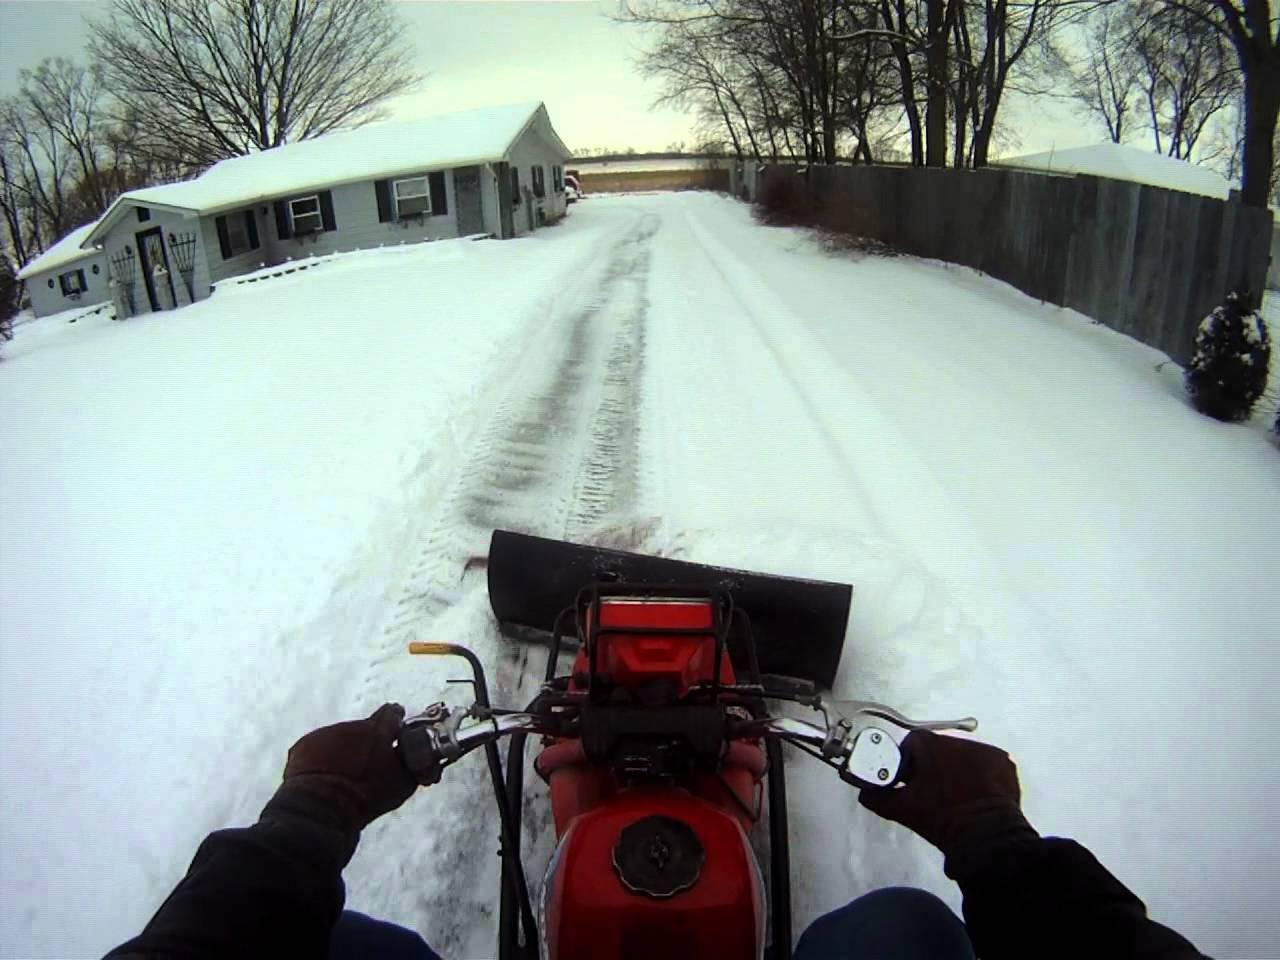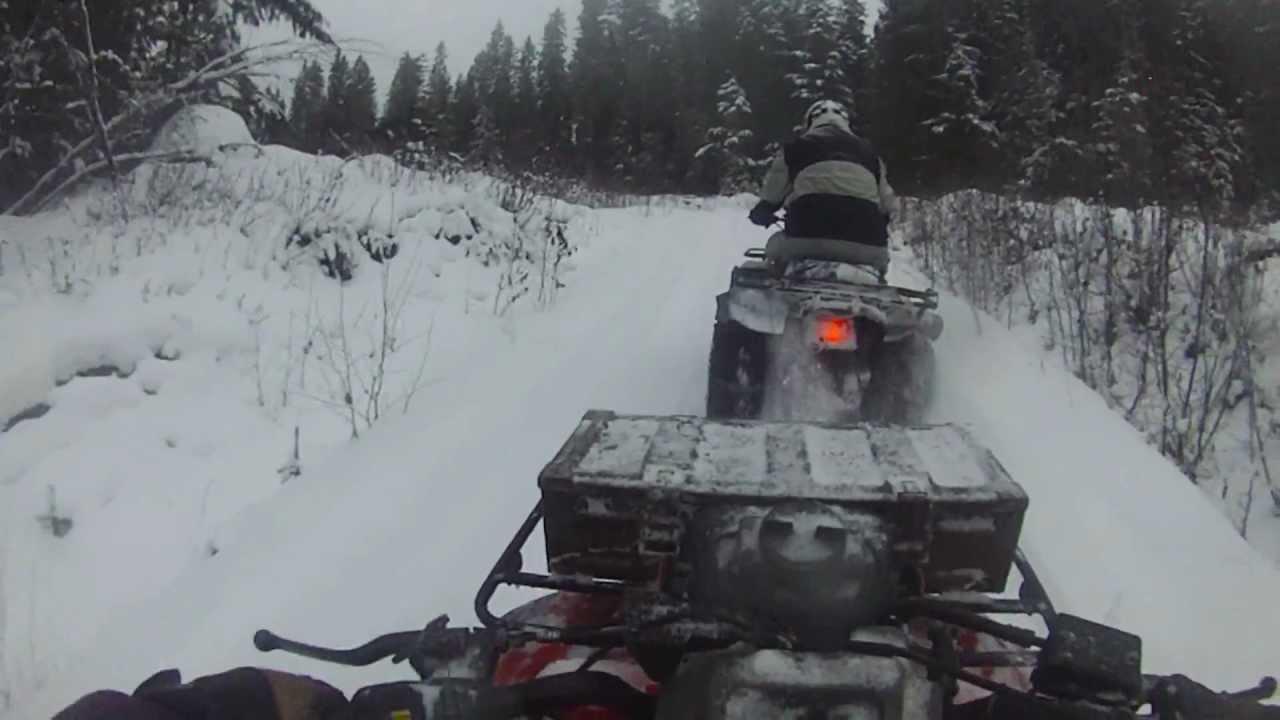The first image is the image on the left, the second image is the image on the right. Examine the images to the left and right. Is the description "There are two 4 wheelers near houses." accurate? Answer yes or no. No. The first image is the image on the left, the second image is the image on the right. For the images displayed, is the sentence "All four wheelers are in snowy areas and have drivers." factually correct? Answer yes or no. Yes. 